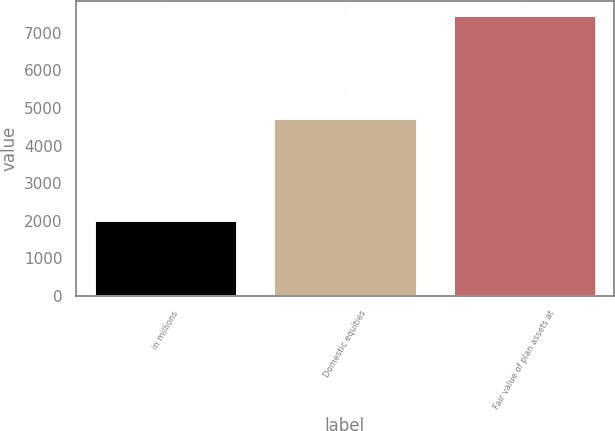Convert chart to OTSL. <chart><loc_0><loc_0><loc_500><loc_500><bar_chart><fcel>in millions<fcel>Domestic equities<fcel>Fair value of plan assets at<nl><fcel>2014<fcel>4729<fcel>7474<nl></chart> 